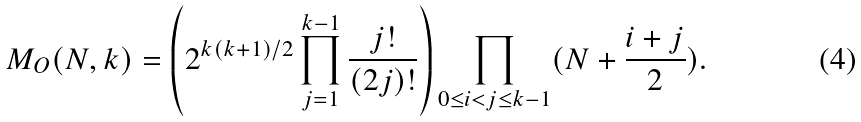Convert formula to latex. <formula><loc_0><loc_0><loc_500><loc_500>M _ { O } ( N , k ) = \left ( 2 ^ { k ( k + 1 ) / 2 } \prod _ { j = 1 } ^ { k - 1 } \frac { j ! } { ( 2 j ) ! } \right ) \prod _ { 0 \leq i < j \leq k - 1 } ( N + \frac { i + j } { 2 } ) .</formula> 